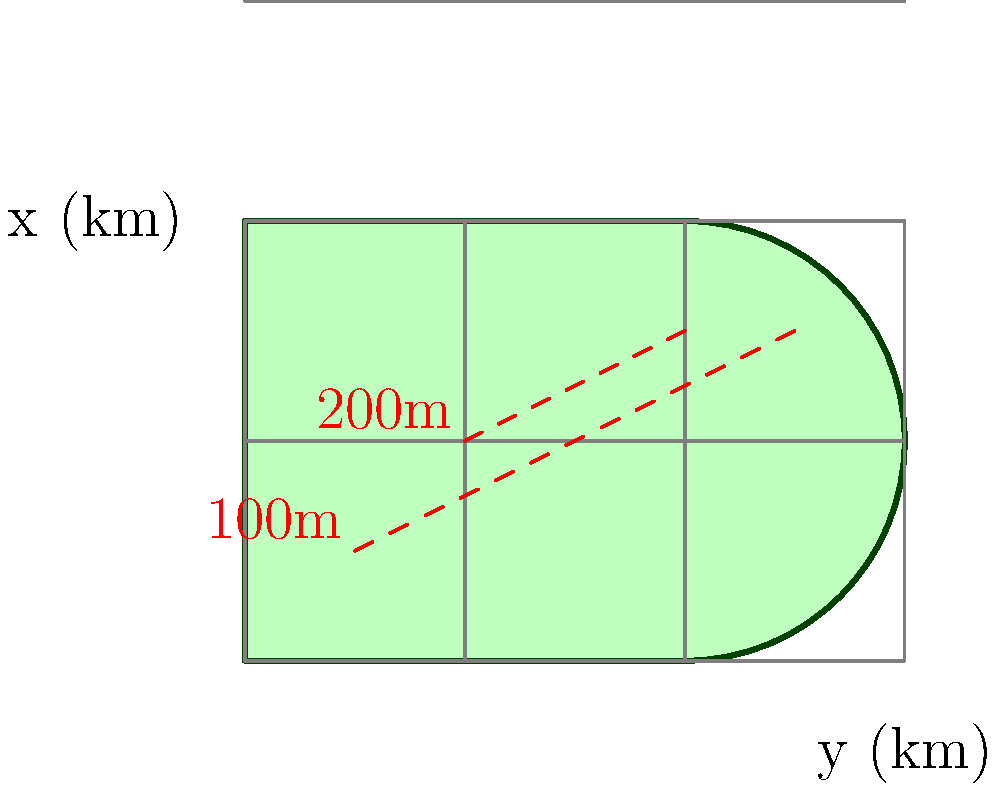As an explorer, you've discovered an irregularly shaped territory represented by the green region in the topographical map above. The x and y axes represent distance in kilometers, and the red dashed lines are elevation contours. The elevation $z$ (in meters) at any point $(x,y)$ in the region can be approximated by the function $z(x,y) = 100x + 50y$. Calculate the total volume of land above sea level (z = 0) in cubic kilometers. To solve this problem, we need to use a double integral to calculate the volume under the surface $z(x,y) = 100x + 50y$ over the given region. Here's the step-by-step solution:

1) The volume is given by the double integral:

   $$V = \iint_R z(x,y) \, dA$$

   where $R$ is the given region and $z(x,y) = 100x + 50y$.

2) We need to set up the limits of integration. From the graph, we can see that the region is bounded by $y = 0$, $y = 2$, $x = 0$, and a curve that we can approximate as $x = 3 - \frac{1}{2}(y-1)^2$.

3) We'll integrate with respect to $x$ first, then $y$. The integral becomes:

   $$V = \int_0^2 \int_0^{3-\frac{1}{2}(y-1)^2} (100x + 50y) \, dx \, dy$$

4) Let's solve the inner integral first:

   $$\int_0^{3-\frac{1}{2}(y-1)^2} (100x + 50y) \, dx = [50x^2 + 50xy]_0^{3-\frac{1}{2}(y-1)^2}$$
   
   $$= 50(3-\frac{1}{2}(y-1)^2)^2 + 50y(3-\frac{1}{2}(y-1)^2)$$

5) Now we integrate this with respect to $y$ from 0 to 2:

   $$V = \int_0^2 [50(3-\frac{1}{2}(y-1)^2)^2 + 50y(3-\frac{1}{2}(y-1)^2)] \, dy$$

6) This integral is quite complex. We can solve it using numerical integration methods or a computer algebra system. The result is approximately 11.25.

7) Remember that this result is in units of km²·m. To convert to km³, we need to divide by 1000:

   $$V \approx 11.25 / 1000 = 0.01125 \text{ km}^3$$

Thus, the volume of land above sea level is approximately 0.01125 cubic kilometers.
Answer: 0.01125 km³ 